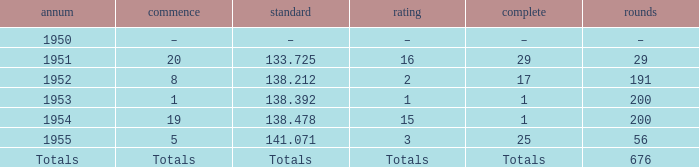Would you be able to parse every entry in this table? {'header': ['annum', 'commence', 'standard', 'rating', 'complete', 'rounds'], 'rows': [['1950', '–', '–', '–', '–', '–'], ['1951', '20', '133.725', '16', '29', '29'], ['1952', '8', '138.212', '2', '17', '191'], ['1953', '1', '138.392', '1', '1', '200'], ['1954', '19', '138.478', '15', '1', '200'], ['1955', '5', '141.071', '3', '25', '56'], ['Totals', 'Totals', 'Totals', 'Totals', 'Totals', '676']]} What is the start of the race with 676 laps? Totals. 